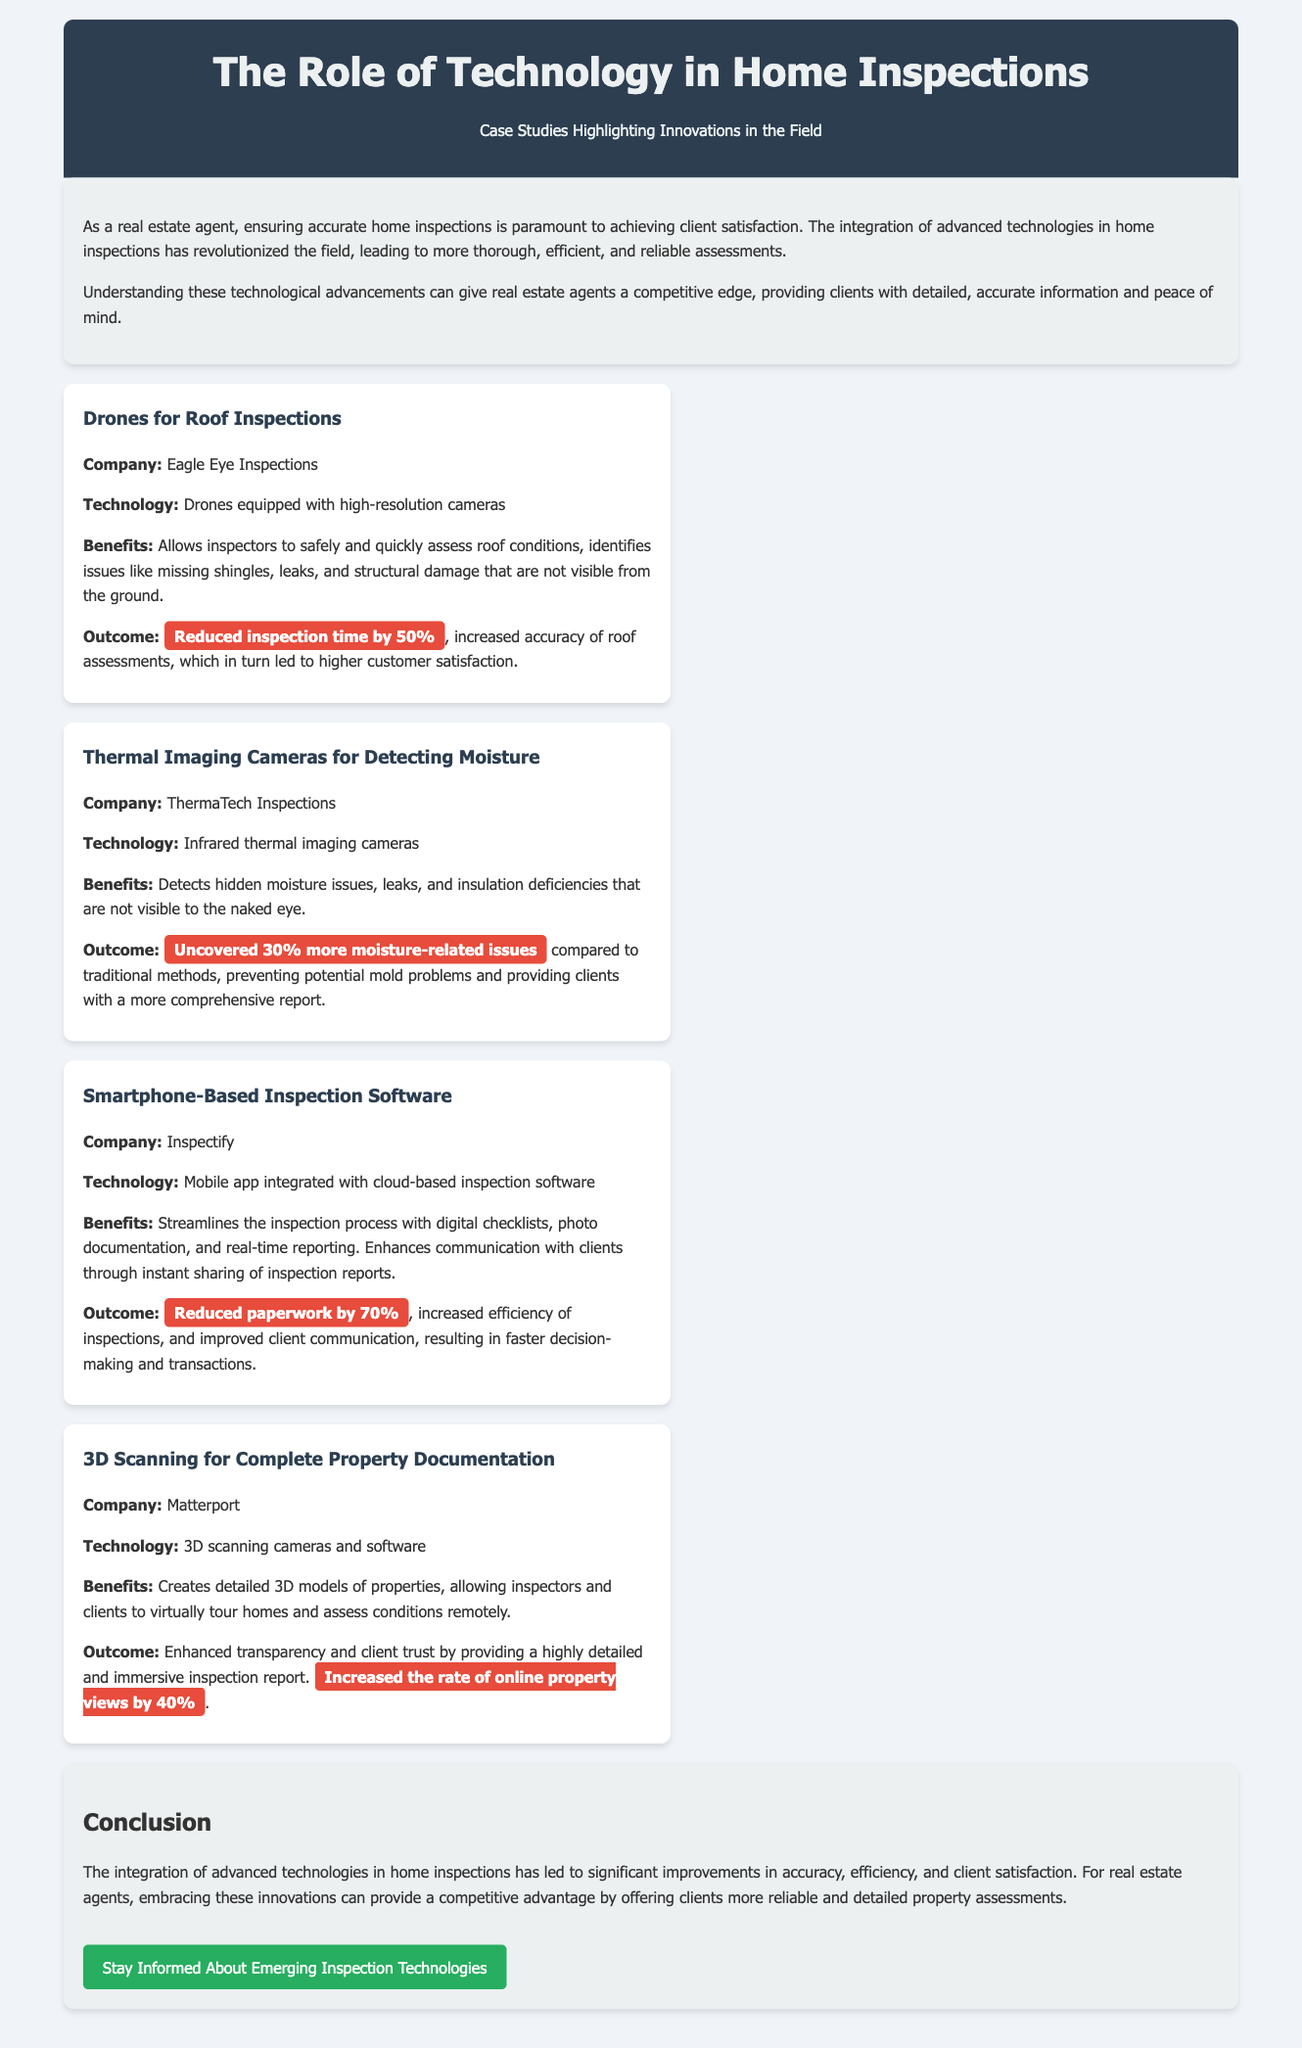what technology did Eagle Eye Inspections use for roof inspections? Eagle Eye Inspections used drones equipped with high-resolution cameras for roof inspections.
Answer: drones equipped with high-resolution cameras how much did drone technology reduce inspection time by? The document states that drone technology reduced inspection time by 50%.
Answer: 50% what percentage more moisture-related issues did ThermaTech Inspections uncover? ThermaTech Inspections uncovered 30% more moisture-related issues compared to traditional methods.
Answer: 30% which company used 3D scanning technology for property documentation? Matterport is the company that used 3D scanning technology for property documentation.
Answer: Matterport what was the result of using smartphone-based inspection software regarding paperwork? The smartphone-based inspection software led to a reduction of paperwork by 70%.
Answer: 70% how did the use of technology impact client communication during inspections? The use of technology improved client communication through instant sharing of inspection reports.
Answer: improved client communication what benefit did 3D scanning provide for client trust? 3D scanning enhanced transparency, providing clients with a highly detailed inspection report.
Answer: enhanced transparency how much did online property views increase due to 3D scanning? The document mentions that online property views increased by 40% due to 3D scanning.
Answer: 40% 